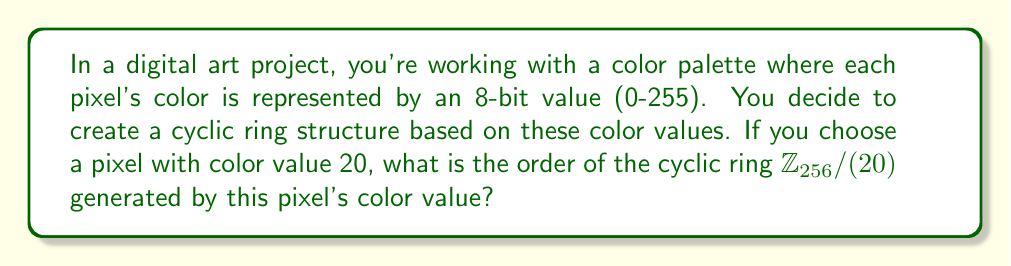What is the answer to this math problem? To determine the order of the cyclic ring $\mathbb{Z}_{256}/(20)$, we need to find the smallest positive integer $n$ such that $20n \equiv 0 \pmod{256}$. This is equivalent to finding the multiplicative order of 20 modulo 256.

Let's break this down step-by-step:

1) First, we need to find the greatest common divisor (GCD) of 20 and 256:
   $\gcd(20, 256) = 4$

2) Now, we can simplify our problem by dividing both numbers by their GCD:
   $\frac{20}{4} = 5$ and $\frac{256}{4} = 64$

3) Our new problem is to find the multiplicative order of 5 modulo 64.

4) We can use the fact that for a prime $p$ and an integer $a$ not divisible by $p$, the order of $a$ modulo $p^k$ divides $\phi(p^k) = p^{k-1}(p-1)$.

5) In our case, $64 = 2^6$, so we're looking for the order of 5 modulo $2^6$.

6) $\phi(2^6) = 2^5 = 32$

7) The possible orders are the divisors of 32: 1, 2, 4, 8, 16, 32

8) We can check these systematically:
   $5^1 \equiv 5 \pmod{64}$
   $5^2 \equiv 25 \pmod{64}$
   $5^4 \equiv 49 \pmod{64}$
   $5^8 \equiv 1 \pmod{64}$

9) We found that $5^8 \equiv 1 \pmod{64}$, so the order of 5 modulo 64 is 8.

10) Remember, we divided by 4 earlier, so we need to multiply our result by 4 to get the final answer.

Therefore, the order of the cyclic ring $\mathbb{Z}_{256}/(20)$ is $4 * 8 = 32$.
Answer: The order of the cyclic ring $\mathbb{Z}_{256}/(20)$ is 32. 